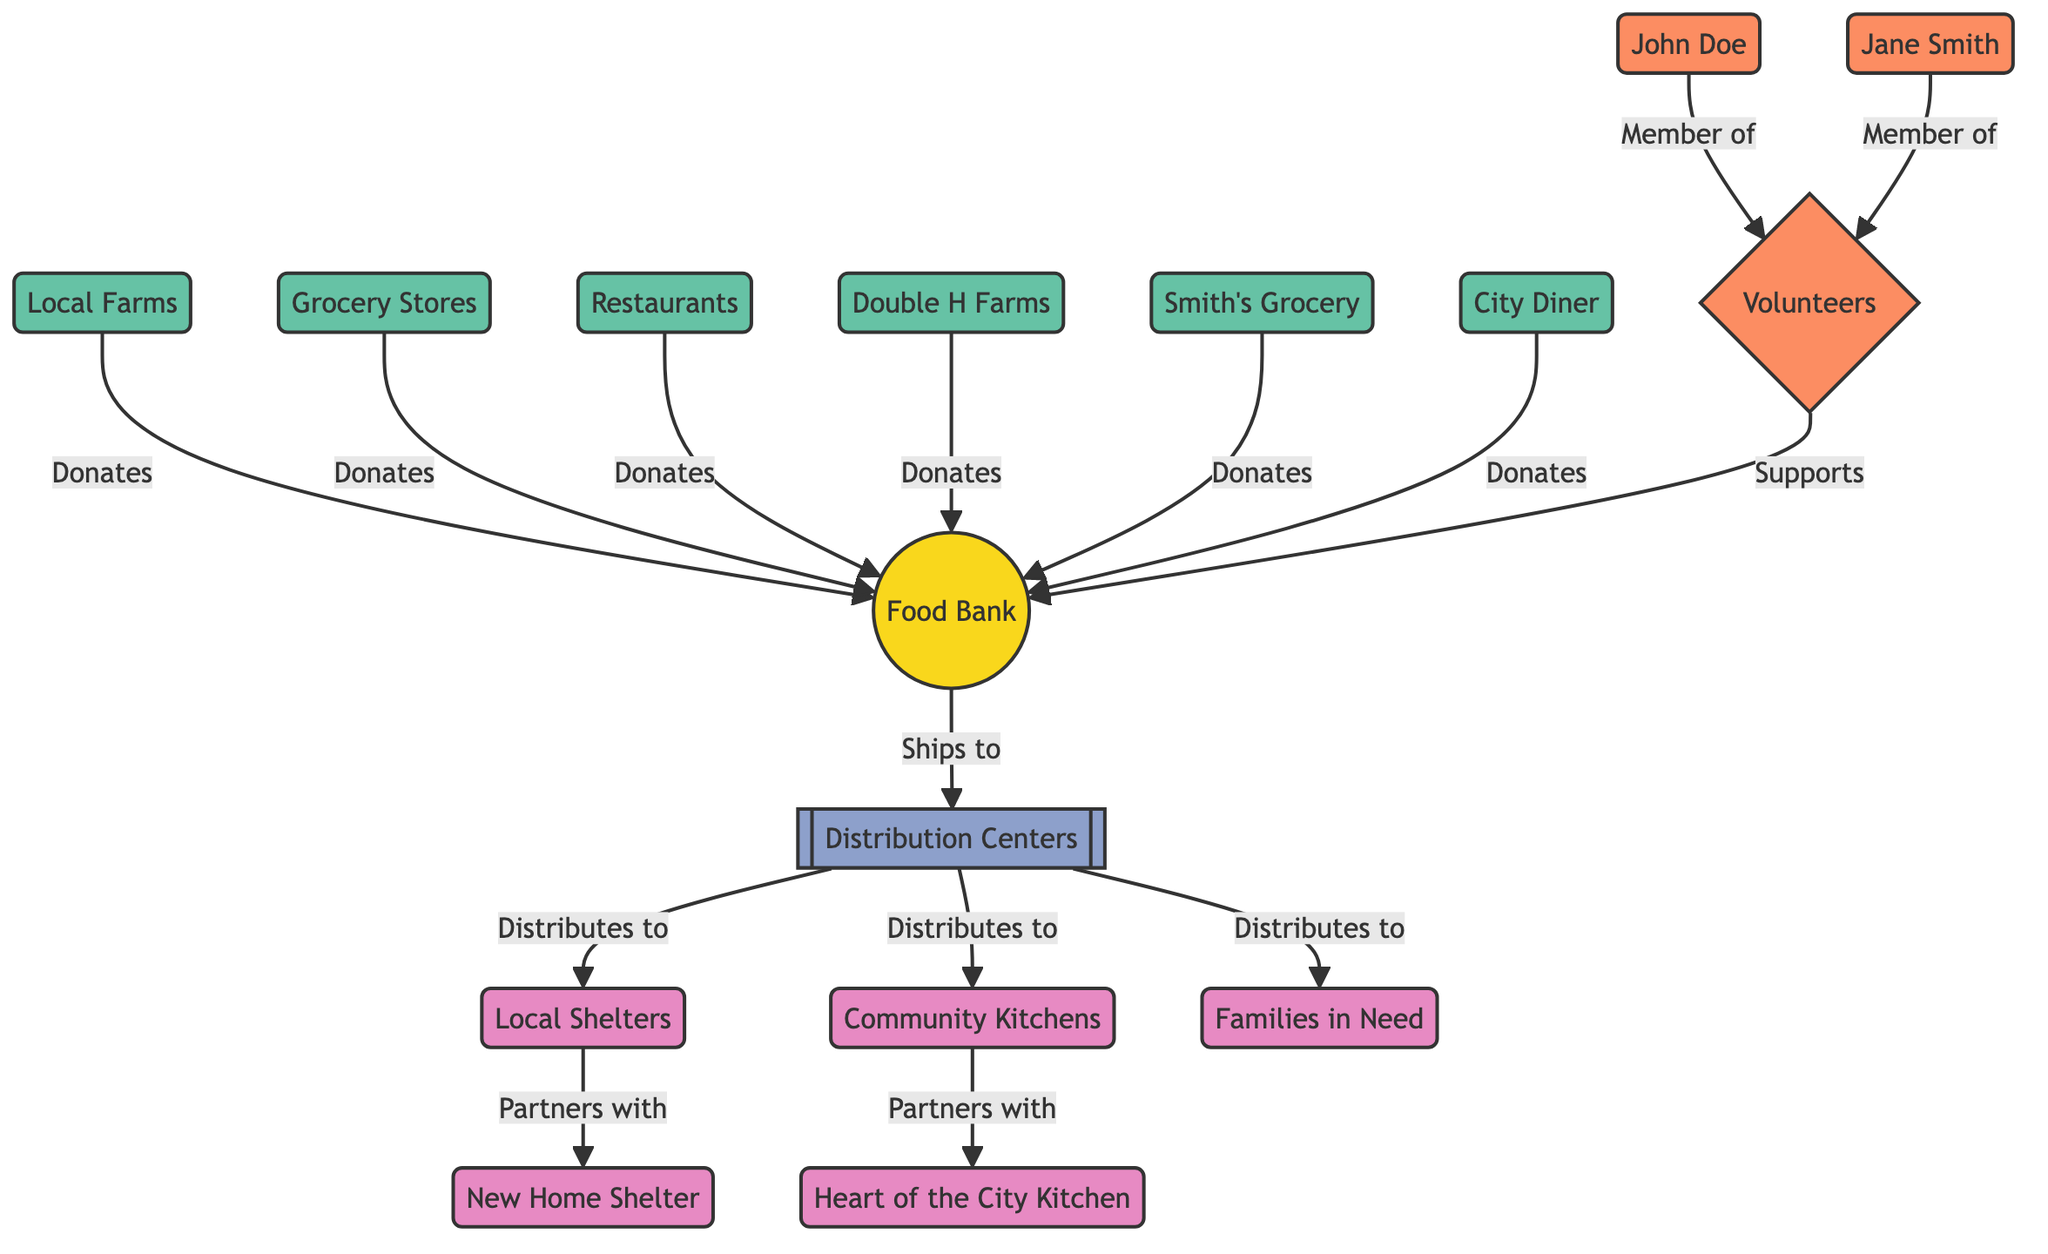What is the total number of donor nodes in the diagram? The diagram lists Local Farms, Grocery Stores, Restaurants, Double H Farms, Smith's Grocery, and City Diner as donor nodes. There are 6 distinct entities categorized as donors.
Answer: 6 Who supports the Food Bank? The diagram shows that the Volunteers group supports the Food Bank, represented by an edge labeled "Supports."
Answer: Volunteers How many recipients are directly connected to the Distribution Centers? The edges indicate that the Distribution Centers distribute food to Local Shelters, Community Kitchens, and Families in Need, which gives us 3 distinct recipients connected directly.
Answer: 3 Which donor is categorized as a store? Among the donor nodes, Smith's Grocery is identified with a category of "Store." This node contains distinguishing information about its type.
Answer: Smith's Grocery What relationship exists between Local Shelters and New Home Shelter? The diagram indicates that Local Shelters partner with New Home Shelter, indicated by an edge labeled "Partners with." This specifies a collaborative relationship between the two recipients.
Answer: Partners with 